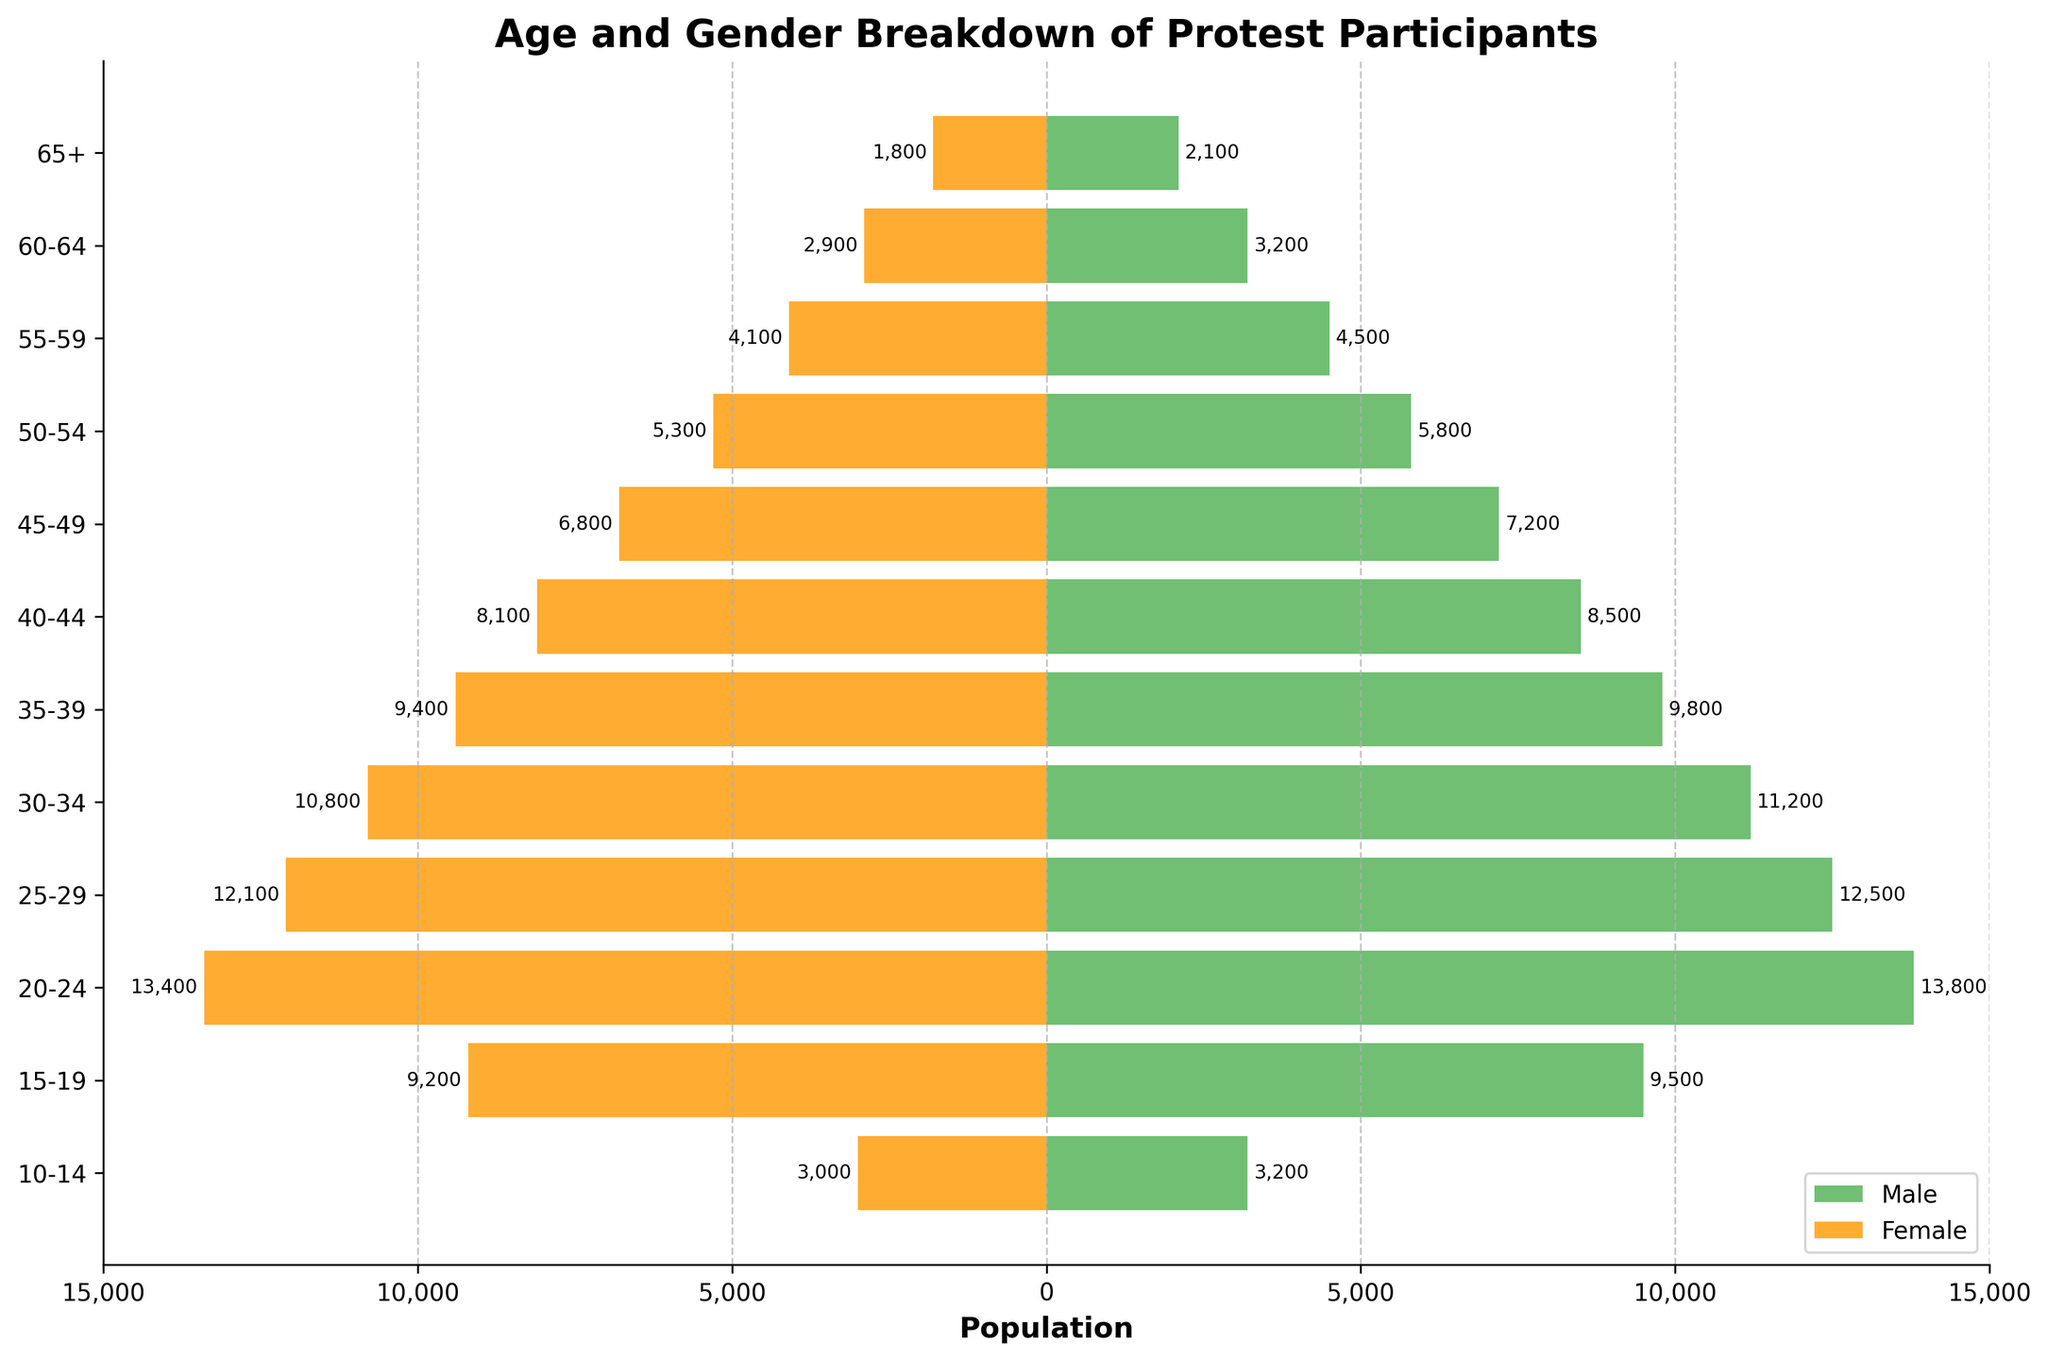What is the title of the figure? The title of the figure is displayed prominently at the top.
Answer: Age and Gender Breakdown of Protest Participants What age group has the highest male population? Find the age group with the longest green bar, representing the male population.
Answer: 20-24 Compare the male and female populations in the 35-39 age group. Which one is larger? Compare the lengths of the green (male) and orange (female) bars for the 35-39 age group.
Answer: Male What is the female population in the 25-29 age group? Locate the 25-29 age group and check the value associated with the orange bar.
Answer: 12,100 Which age group has the smallest female population? Identify the age group with the shortest orange bar.
Answer: 10-14 How many participants are there in total for the 20-24 age group? Sum the male and female populations for the 20-24 age group (13,800 + 13,400).
Answer: 27,200 What is the difference between the male and female populations in the 45-49 age group? Subtract the female population from the male population in the 45-49 age group (7,200 - 6,800).
Answer: 400 How does the population of males aged 30-34 compare to that of females aged 20-24? Compare the values associated with the green bar for 30-34 males and the orange bar for 20-24 females (11,200 vs. 13,400).
Answer: Females aged 20-24 What age group has the highest combined male and female population in the figure? Sum the male and female populations for all age groups and identify the maximum. The highest combined is in the 20-24 age group (13,800 + 13,400).
Answer: 20-24 Which age group has a difference of 600 participants between male and female populations? Subtract the female population from the male population for each age group and identify the one with a 600 difference. The 60-64 age group has a difference (3,200 - 2,900).
Answer: 60-64 